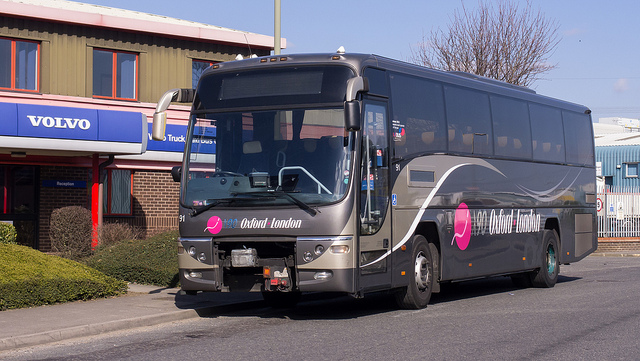Read and extract the text from this image. VOLVO Truck Onford london London Oxford 90 